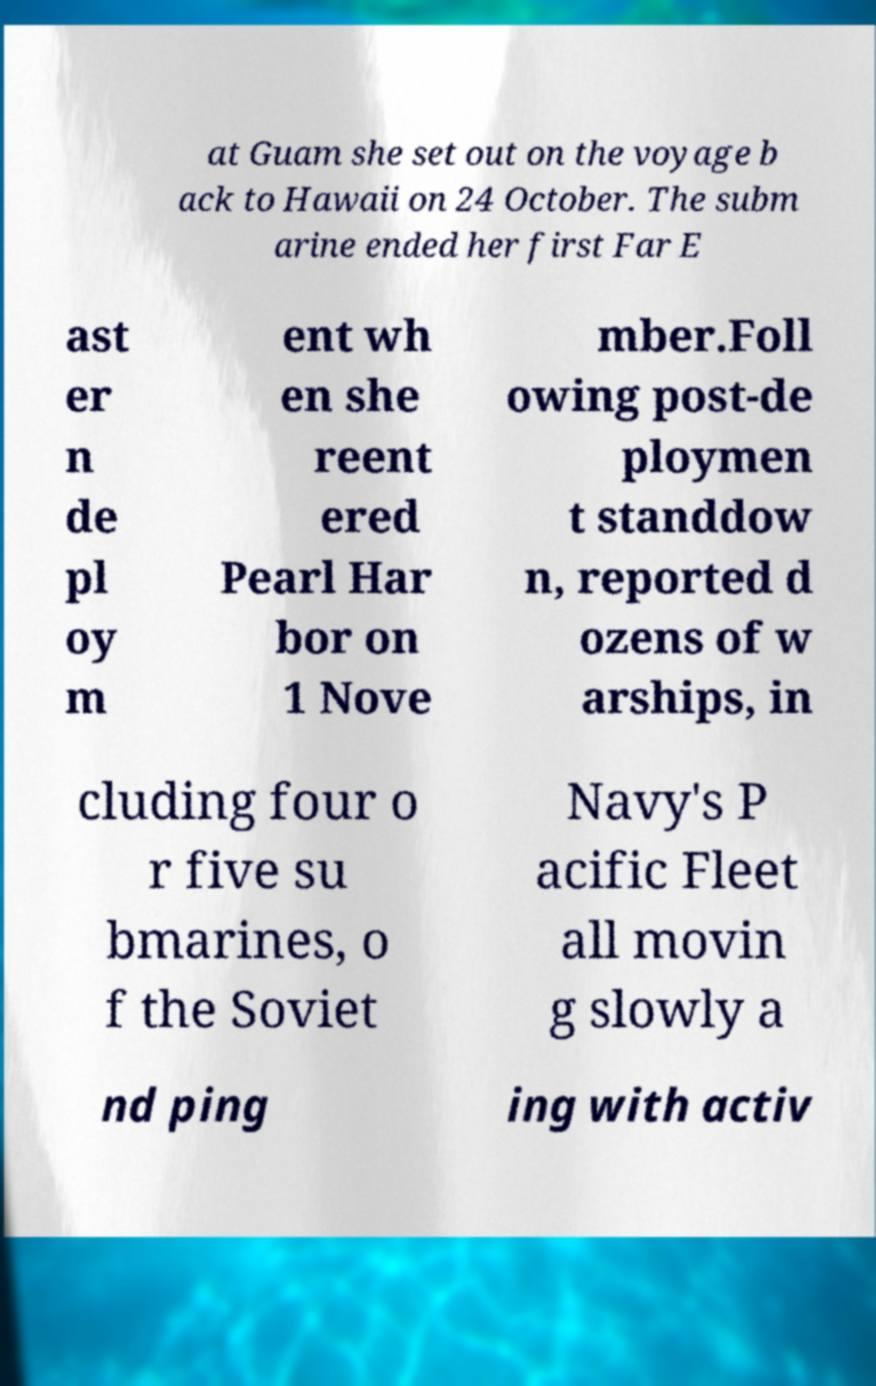Could you extract and type out the text from this image? at Guam she set out on the voyage b ack to Hawaii on 24 October. The subm arine ended her first Far E ast er n de pl oy m ent wh en she reent ered Pearl Har bor on 1 Nove mber.Foll owing post-de ploymen t standdow n, reported d ozens of w arships, in cluding four o r five su bmarines, o f the Soviet Navy's P acific Fleet all movin g slowly a nd ping ing with activ 